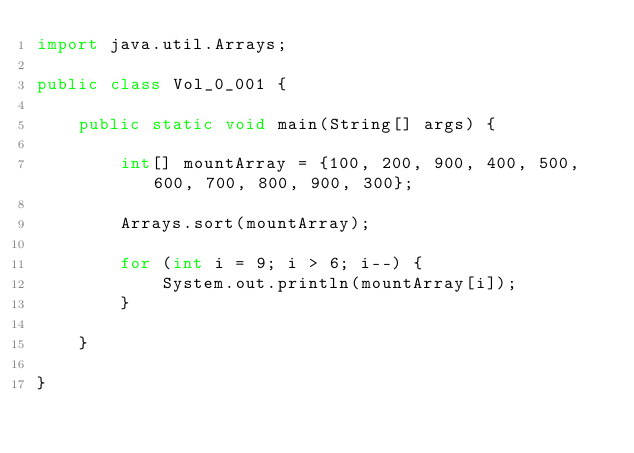Convert code to text. <code><loc_0><loc_0><loc_500><loc_500><_Java_>import java.util.Arrays;

public class Vol_0_001 {

    public static void main(String[] args) {

        int[] mountArray = {100, 200, 900, 400, 500, 600, 700, 800, 900, 300};

        Arrays.sort(mountArray);

        for (int i = 9; i > 6; i--) {
            System.out.println(mountArray[i]);
        }

    }

}</code> 